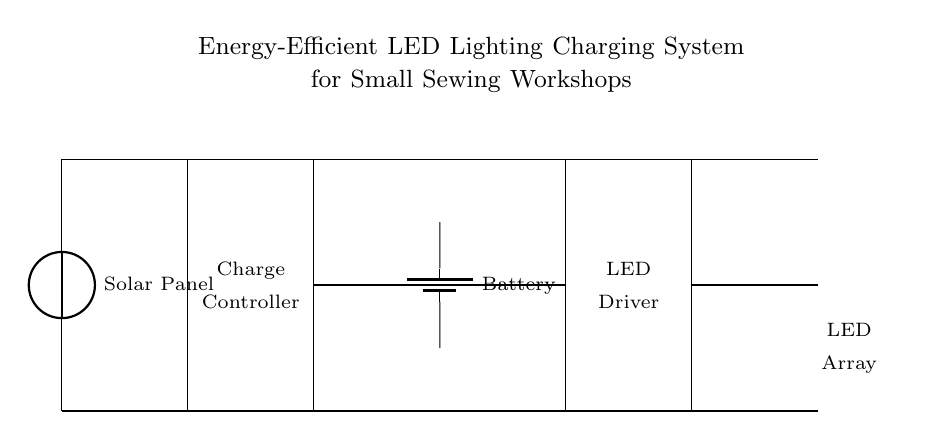What is the purpose of the Solar Panel? The Solar Panel generates electricity from sunlight, which is the primary energy source for this system. It converts solar energy into electrical energy, supplying power to charge the battery and to eventually power the LED lights.
Answer: Electricity generation What component controls the charging process? The Charge Controller manages the voltage and current coming from the solar panel before it reaches the battery. It ensures that the battery is charged safely without being overcharged, thus prolonging its life and maintaining efficiency.
Answer: Charge Controller How many LEDs are present in the LED Array? There are three LED lights shown in the LED Array section of the circuit. The diagram displays three LED symbols placed in a row, indicating that three individual LEDs are connected for lighting purposes.
Answer: Three What is the role of the Battery in this circuit? The Battery stores electrical energy generated by the Solar Panel for later use, providing power to the LED Driver and, consequently, to the LED Array when needed. Without the battery, energy would not be available during times when sunlight is not present.
Answer: Energy storage What connects the Charge Controller to the Battery? A direct connection line can be seen that runs from the Charge Controller to the Battery, which allows for the controlled flow of electricity from the Solar Panel, through the Charge Controller, to the Battery for charging.
Answer: Direct connection Which component supplies power to the LED Driver? The Battery supplies power to the LED Driver in this circuit. After being charged by the Solar Panel through the Charge Controller, the battery subsequently powers the LED Driver that drives the LED Array for lighting.
Answer: Battery 